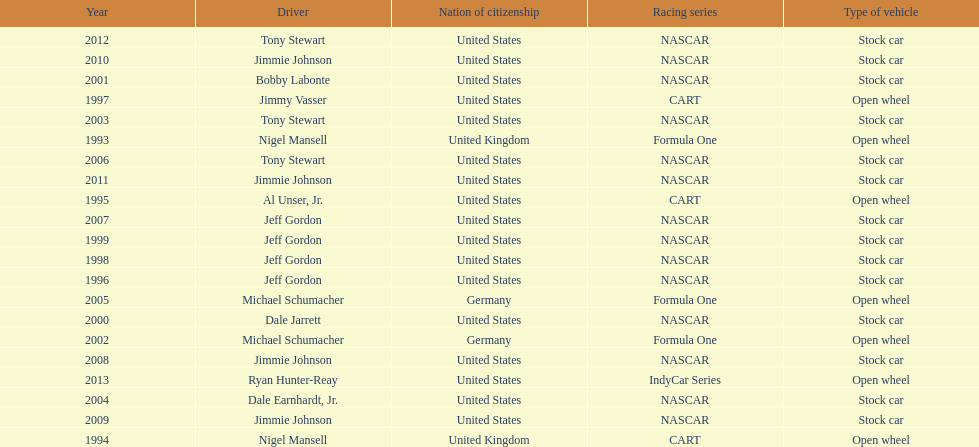Does the united states have more nation of citzenship then united kingdom? Yes. 